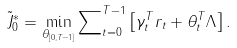<formula> <loc_0><loc_0><loc_500><loc_500>\tilde { J } _ { 0 } ^ { * } = \min _ { \theta _ { [ 0 , T - 1 ] } } \sum \nolimits _ { t = 0 } ^ { T - 1 } \left [ \gamma _ { t } ^ { T } r _ { t } + \theta _ { t } ^ { T } \Lambda \right ] .</formula> 